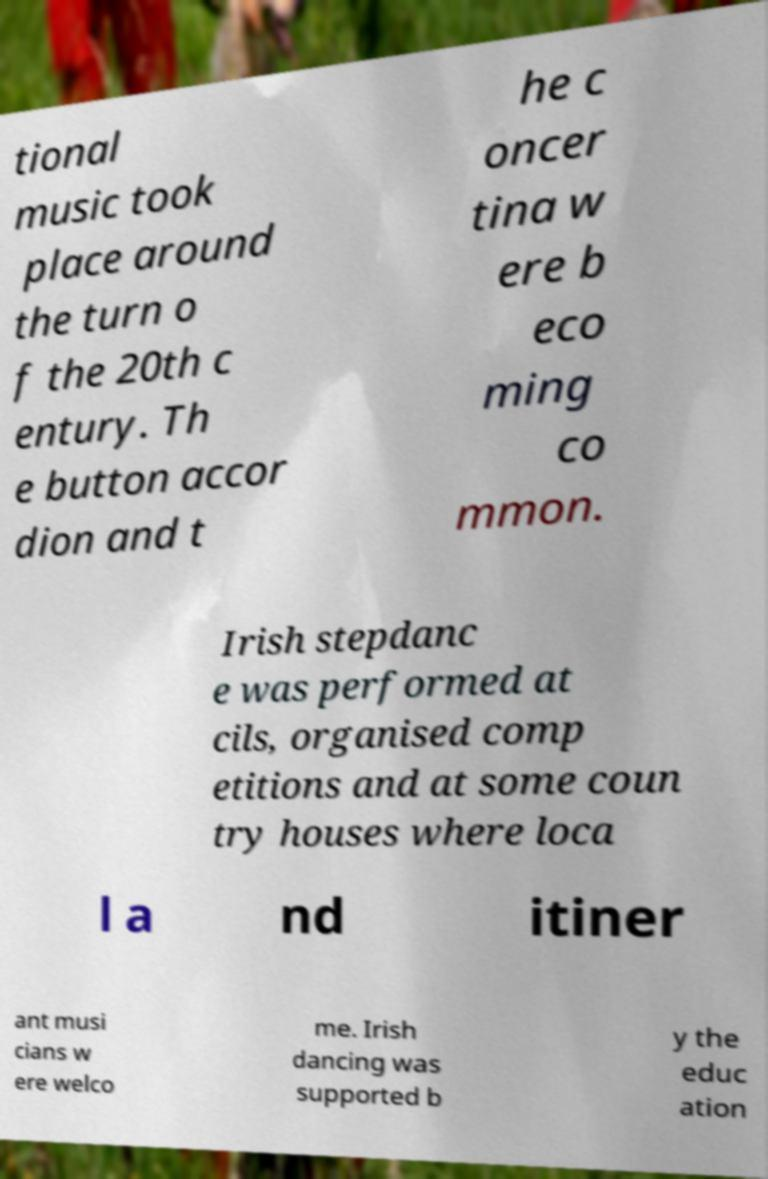There's text embedded in this image that I need extracted. Can you transcribe it verbatim? tional music took place around the turn o f the 20th c entury. Th e button accor dion and t he c oncer tina w ere b eco ming co mmon. Irish stepdanc e was performed at cils, organised comp etitions and at some coun try houses where loca l a nd itiner ant musi cians w ere welco me. Irish dancing was supported b y the educ ation 